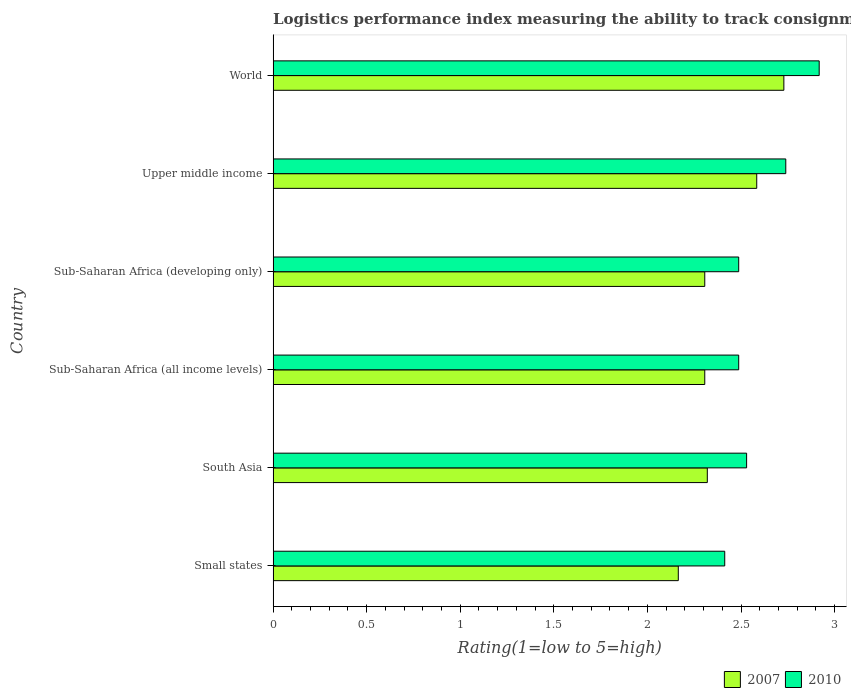How many different coloured bars are there?
Provide a succinct answer. 2. How many groups of bars are there?
Offer a very short reply. 6. Are the number of bars per tick equal to the number of legend labels?
Your answer should be very brief. Yes. Are the number of bars on each tick of the Y-axis equal?
Keep it short and to the point. Yes. How many bars are there on the 5th tick from the top?
Provide a succinct answer. 2. How many bars are there on the 2nd tick from the bottom?
Your response must be concise. 2. In how many cases, is the number of bars for a given country not equal to the number of legend labels?
Your response must be concise. 0. What is the Logistic performance index in 2010 in Upper middle income?
Keep it short and to the point. 2.74. Across all countries, what is the maximum Logistic performance index in 2010?
Give a very brief answer. 2.92. Across all countries, what is the minimum Logistic performance index in 2010?
Provide a short and direct response. 2.41. In which country was the Logistic performance index in 2010 minimum?
Provide a short and direct response. Small states. What is the total Logistic performance index in 2007 in the graph?
Your answer should be very brief. 14.41. What is the difference between the Logistic performance index in 2007 in South Asia and that in Upper middle income?
Provide a succinct answer. -0.26. What is the difference between the Logistic performance index in 2007 in South Asia and the Logistic performance index in 2010 in Upper middle income?
Provide a short and direct response. -0.42. What is the average Logistic performance index in 2010 per country?
Offer a very short reply. 2.6. What is the difference between the Logistic performance index in 2007 and Logistic performance index in 2010 in South Asia?
Your answer should be compact. -0.21. What is the ratio of the Logistic performance index in 2007 in Sub-Saharan Africa (developing only) to that in World?
Give a very brief answer. 0.85. Is the Logistic performance index in 2007 in Small states less than that in South Asia?
Your answer should be compact. Yes. What is the difference between the highest and the second highest Logistic performance index in 2010?
Your answer should be compact. 0.18. What is the difference between the highest and the lowest Logistic performance index in 2007?
Provide a succinct answer. 0.56. Is the sum of the Logistic performance index in 2007 in Sub-Saharan Africa (all income levels) and World greater than the maximum Logistic performance index in 2010 across all countries?
Ensure brevity in your answer.  Yes. What does the 1st bar from the top in World represents?
Give a very brief answer. 2010. How many countries are there in the graph?
Keep it short and to the point. 6. What is the difference between two consecutive major ticks on the X-axis?
Provide a succinct answer. 0.5. Does the graph contain any zero values?
Your answer should be very brief. No. Does the graph contain grids?
Offer a very short reply. No. What is the title of the graph?
Give a very brief answer. Logistics performance index measuring the ability to track consignments when shipping to a market. What is the label or title of the X-axis?
Offer a very short reply. Rating(1=low to 5=high). What is the label or title of the Y-axis?
Give a very brief answer. Country. What is the Rating(1=low to 5=high) of 2007 in Small states?
Provide a succinct answer. 2.17. What is the Rating(1=low to 5=high) of 2010 in Small states?
Your answer should be very brief. 2.41. What is the Rating(1=low to 5=high) in 2007 in South Asia?
Your answer should be compact. 2.32. What is the Rating(1=low to 5=high) of 2010 in South Asia?
Your answer should be compact. 2.53. What is the Rating(1=low to 5=high) of 2007 in Sub-Saharan Africa (all income levels)?
Your answer should be compact. 2.31. What is the Rating(1=low to 5=high) of 2010 in Sub-Saharan Africa (all income levels)?
Make the answer very short. 2.49. What is the Rating(1=low to 5=high) in 2007 in Sub-Saharan Africa (developing only)?
Your answer should be very brief. 2.31. What is the Rating(1=low to 5=high) of 2010 in Sub-Saharan Africa (developing only)?
Your answer should be compact. 2.49. What is the Rating(1=low to 5=high) of 2007 in Upper middle income?
Offer a terse response. 2.58. What is the Rating(1=low to 5=high) in 2010 in Upper middle income?
Provide a short and direct response. 2.74. What is the Rating(1=low to 5=high) in 2007 in World?
Offer a very short reply. 2.73. What is the Rating(1=low to 5=high) of 2010 in World?
Your answer should be compact. 2.92. Across all countries, what is the maximum Rating(1=low to 5=high) of 2007?
Your response must be concise. 2.73. Across all countries, what is the maximum Rating(1=low to 5=high) in 2010?
Your answer should be very brief. 2.92. Across all countries, what is the minimum Rating(1=low to 5=high) in 2007?
Your answer should be compact. 2.17. Across all countries, what is the minimum Rating(1=low to 5=high) in 2010?
Give a very brief answer. 2.41. What is the total Rating(1=low to 5=high) in 2007 in the graph?
Offer a terse response. 14.41. What is the total Rating(1=low to 5=high) of 2010 in the graph?
Your answer should be very brief. 15.58. What is the difference between the Rating(1=low to 5=high) in 2007 in Small states and that in South Asia?
Give a very brief answer. -0.15. What is the difference between the Rating(1=low to 5=high) of 2010 in Small states and that in South Asia?
Offer a very short reply. -0.12. What is the difference between the Rating(1=low to 5=high) in 2007 in Small states and that in Sub-Saharan Africa (all income levels)?
Ensure brevity in your answer.  -0.14. What is the difference between the Rating(1=low to 5=high) of 2010 in Small states and that in Sub-Saharan Africa (all income levels)?
Ensure brevity in your answer.  -0.07. What is the difference between the Rating(1=low to 5=high) in 2007 in Small states and that in Sub-Saharan Africa (developing only)?
Make the answer very short. -0.14. What is the difference between the Rating(1=low to 5=high) of 2010 in Small states and that in Sub-Saharan Africa (developing only)?
Ensure brevity in your answer.  -0.07. What is the difference between the Rating(1=low to 5=high) in 2007 in Small states and that in Upper middle income?
Give a very brief answer. -0.42. What is the difference between the Rating(1=low to 5=high) of 2010 in Small states and that in Upper middle income?
Make the answer very short. -0.33. What is the difference between the Rating(1=low to 5=high) in 2007 in Small states and that in World?
Provide a short and direct response. -0.56. What is the difference between the Rating(1=low to 5=high) in 2010 in Small states and that in World?
Keep it short and to the point. -0.5. What is the difference between the Rating(1=low to 5=high) in 2007 in South Asia and that in Sub-Saharan Africa (all income levels)?
Your answer should be very brief. 0.01. What is the difference between the Rating(1=low to 5=high) in 2010 in South Asia and that in Sub-Saharan Africa (all income levels)?
Your response must be concise. 0.04. What is the difference between the Rating(1=low to 5=high) of 2007 in South Asia and that in Sub-Saharan Africa (developing only)?
Keep it short and to the point. 0.01. What is the difference between the Rating(1=low to 5=high) of 2010 in South Asia and that in Sub-Saharan Africa (developing only)?
Your answer should be very brief. 0.04. What is the difference between the Rating(1=low to 5=high) in 2007 in South Asia and that in Upper middle income?
Provide a short and direct response. -0.26. What is the difference between the Rating(1=low to 5=high) of 2010 in South Asia and that in Upper middle income?
Your answer should be compact. -0.21. What is the difference between the Rating(1=low to 5=high) in 2007 in South Asia and that in World?
Offer a very short reply. -0.41. What is the difference between the Rating(1=low to 5=high) in 2010 in South Asia and that in World?
Offer a very short reply. -0.39. What is the difference between the Rating(1=low to 5=high) of 2010 in Sub-Saharan Africa (all income levels) and that in Sub-Saharan Africa (developing only)?
Your answer should be very brief. 0. What is the difference between the Rating(1=low to 5=high) of 2007 in Sub-Saharan Africa (all income levels) and that in Upper middle income?
Provide a short and direct response. -0.28. What is the difference between the Rating(1=low to 5=high) of 2010 in Sub-Saharan Africa (all income levels) and that in Upper middle income?
Provide a succinct answer. -0.25. What is the difference between the Rating(1=low to 5=high) of 2007 in Sub-Saharan Africa (all income levels) and that in World?
Keep it short and to the point. -0.42. What is the difference between the Rating(1=low to 5=high) of 2010 in Sub-Saharan Africa (all income levels) and that in World?
Your answer should be compact. -0.43. What is the difference between the Rating(1=low to 5=high) of 2007 in Sub-Saharan Africa (developing only) and that in Upper middle income?
Give a very brief answer. -0.28. What is the difference between the Rating(1=low to 5=high) in 2010 in Sub-Saharan Africa (developing only) and that in Upper middle income?
Make the answer very short. -0.25. What is the difference between the Rating(1=low to 5=high) in 2007 in Sub-Saharan Africa (developing only) and that in World?
Offer a terse response. -0.42. What is the difference between the Rating(1=low to 5=high) in 2010 in Sub-Saharan Africa (developing only) and that in World?
Provide a succinct answer. -0.43. What is the difference between the Rating(1=low to 5=high) in 2007 in Upper middle income and that in World?
Provide a short and direct response. -0.14. What is the difference between the Rating(1=low to 5=high) of 2010 in Upper middle income and that in World?
Keep it short and to the point. -0.18. What is the difference between the Rating(1=low to 5=high) of 2007 in Small states and the Rating(1=low to 5=high) of 2010 in South Asia?
Ensure brevity in your answer.  -0.36. What is the difference between the Rating(1=low to 5=high) in 2007 in Small states and the Rating(1=low to 5=high) in 2010 in Sub-Saharan Africa (all income levels)?
Offer a terse response. -0.32. What is the difference between the Rating(1=low to 5=high) in 2007 in Small states and the Rating(1=low to 5=high) in 2010 in Sub-Saharan Africa (developing only)?
Your answer should be very brief. -0.32. What is the difference between the Rating(1=low to 5=high) in 2007 in Small states and the Rating(1=low to 5=high) in 2010 in Upper middle income?
Keep it short and to the point. -0.57. What is the difference between the Rating(1=low to 5=high) in 2007 in Small states and the Rating(1=low to 5=high) in 2010 in World?
Your response must be concise. -0.75. What is the difference between the Rating(1=low to 5=high) in 2007 in South Asia and the Rating(1=low to 5=high) in 2010 in Sub-Saharan Africa (all income levels)?
Give a very brief answer. -0.17. What is the difference between the Rating(1=low to 5=high) of 2007 in South Asia and the Rating(1=low to 5=high) of 2010 in Sub-Saharan Africa (developing only)?
Your answer should be very brief. -0.17. What is the difference between the Rating(1=low to 5=high) in 2007 in South Asia and the Rating(1=low to 5=high) in 2010 in Upper middle income?
Make the answer very short. -0.42. What is the difference between the Rating(1=low to 5=high) of 2007 in South Asia and the Rating(1=low to 5=high) of 2010 in World?
Your response must be concise. -0.6. What is the difference between the Rating(1=low to 5=high) in 2007 in Sub-Saharan Africa (all income levels) and the Rating(1=low to 5=high) in 2010 in Sub-Saharan Africa (developing only)?
Your answer should be compact. -0.18. What is the difference between the Rating(1=low to 5=high) in 2007 in Sub-Saharan Africa (all income levels) and the Rating(1=low to 5=high) in 2010 in Upper middle income?
Offer a terse response. -0.43. What is the difference between the Rating(1=low to 5=high) in 2007 in Sub-Saharan Africa (all income levels) and the Rating(1=low to 5=high) in 2010 in World?
Offer a terse response. -0.61. What is the difference between the Rating(1=low to 5=high) of 2007 in Sub-Saharan Africa (developing only) and the Rating(1=low to 5=high) of 2010 in Upper middle income?
Your answer should be compact. -0.43. What is the difference between the Rating(1=low to 5=high) in 2007 in Sub-Saharan Africa (developing only) and the Rating(1=low to 5=high) in 2010 in World?
Give a very brief answer. -0.61. What is the difference between the Rating(1=low to 5=high) of 2007 in Upper middle income and the Rating(1=low to 5=high) of 2010 in World?
Offer a terse response. -0.33. What is the average Rating(1=low to 5=high) of 2007 per country?
Ensure brevity in your answer.  2.4. What is the average Rating(1=low to 5=high) of 2010 per country?
Keep it short and to the point. 2.6. What is the difference between the Rating(1=low to 5=high) of 2007 and Rating(1=low to 5=high) of 2010 in Small states?
Your answer should be compact. -0.25. What is the difference between the Rating(1=low to 5=high) in 2007 and Rating(1=low to 5=high) in 2010 in South Asia?
Ensure brevity in your answer.  -0.21. What is the difference between the Rating(1=low to 5=high) in 2007 and Rating(1=low to 5=high) in 2010 in Sub-Saharan Africa (all income levels)?
Your answer should be very brief. -0.18. What is the difference between the Rating(1=low to 5=high) of 2007 and Rating(1=low to 5=high) of 2010 in Sub-Saharan Africa (developing only)?
Your answer should be compact. -0.18. What is the difference between the Rating(1=low to 5=high) in 2007 and Rating(1=low to 5=high) in 2010 in Upper middle income?
Offer a terse response. -0.16. What is the difference between the Rating(1=low to 5=high) in 2007 and Rating(1=low to 5=high) in 2010 in World?
Offer a terse response. -0.19. What is the ratio of the Rating(1=low to 5=high) in 2007 in Small states to that in South Asia?
Offer a terse response. 0.93. What is the ratio of the Rating(1=low to 5=high) in 2010 in Small states to that in South Asia?
Ensure brevity in your answer.  0.95. What is the ratio of the Rating(1=low to 5=high) of 2007 in Small states to that in Sub-Saharan Africa (all income levels)?
Offer a terse response. 0.94. What is the ratio of the Rating(1=low to 5=high) of 2010 in Small states to that in Sub-Saharan Africa (all income levels)?
Provide a short and direct response. 0.97. What is the ratio of the Rating(1=low to 5=high) of 2007 in Small states to that in Sub-Saharan Africa (developing only)?
Your answer should be compact. 0.94. What is the ratio of the Rating(1=low to 5=high) in 2010 in Small states to that in Sub-Saharan Africa (developing only)?
Offer a very short reply. 0.97. What is the ratio of the Rating(1=low to 5=high) in 2007 in Small states to that in Upper middle income?
Your response must be concise. 0.84. What is the ratio of the Rating(1=low to 5=high) of 2010 in Small states to that in Upper middle income?
Make the answer very short. 0.88. What is the ratio of the Rating(1=low to 5=high) of 2007 in Small states to that in World?
Keep it short and to the point. 0.79. What is the ratio of the Rating(1=low to 5=high) of 2010 in Small states to that in World?
Your answer should be compact. 0.83. What is the ratio of the Rating(1=low to 5=high) of 2007 in South Asia to that in Sub-Saharan Africa (all income levels)?
Your answer should be very brief. 1.01. What is the ratio of the Rating(1=low to 5=high) in 2007 in South Asia to that in Sub-Saharan Africa (developing only)?
Ensure brevity in your answer.  1.01. What is the ratio of the Rating(1=low to 5=high) in 2010 in South Asia to that in Sub-Saharan Africa (developing only)?
Offer a terse response. 1.02. What is the ratio of the Rating(1=low to 5=high) in 2007 in South Asia to that in Upper middle income?
Offer a very short reply. 0.9. What is the ratio of the Rating(1=low to 5=high) in 2010 in South Asia to that in Upper middle income?
Keep it short and to the point. 0.92. What is the ratio of the Rating(1=low to 5=high) in 2007 in South Asia to that in World?
Ensure brevity in your answer.  0.85. What is the ratio of the Rating(1=low to 5=high) in 2010 in South Asia to that in World?
Your answer should be very brief. 0.87. What is the ratio of the Rating(1=low to 5=high) of 2010 in Sub-Saharan Africa (all income levels) to that in Sub-Saharan Africa (developing only)?
Give a very brief answer. 1. What is the ratio of the Rating(1=low to 5=high) of 2007 in Sub-Saharan Africa (all income levels) to that in Upper middle income?
Your answer should be compact. 0.89. What is the ratio of the Rating(1=low to 5=high) of 2010 in Sub-Saharan Africa (all income levels) to that in Upper middle income?
Make the answer very short. 0.91. What is the ratio of the Rating(1=low to 5=high) in 2007 in Sub-Saharan Africa (all income levels) to that in World?
Provide a short and direct response. 0.85. What is the ratio of the Rating(1=low to 5=high) in 2010 in Sub-Saharan Africa (all income levels) to that in World?
Give a very brief answer. 0.85. What is the ratio of the Rating(1=low to 5=high) of 2007 in Sub-Saharan Africa (developing only) to that in Upper middle income?
Provide a short and direct response. 0.89. What is the ratio of the Rating(1=low to 5=high) of 2010 in Sub-Saharan Africa (developing only) to that in Upper middle income?
Provide a short and direct response. 0.91. What is the ratio of the Rating(1=low to 5=high) of 2007 in Sub-Saharan Africa (developing only) to that in World?
Provide a short and direct response. 0.85. What is the ratio of the Rating(1=low to 5=high) in 2010 in Sub-Saharan Africa (developing only) to that in World?
Your response must be concise. 0.85. What is the ratio of the Rating(1=low to 5=high) in 2007 in Upper middle income to that in World?
Keep it short and to the point. 0.95. What is the ratio of the Rating(1=low to 5=high) of 2010 in Upper middle income to that in World?
Provide a short and direct response. 0.94. What is the difference between the highest and the second highest Rating(1=low to 5=high) in 2007?
Offer a terse response. 0.14. What is the difference between the highest and the second highest Rating(1=low to 5=high) in 2010?
Keep it short and to the point. 0.18. What is the difference between the highest and the lowest Rating(1=low to 5=high) of 2007?
Provide a short and direct response. 0.56. What is the difference between the highest and the lowest Rating(1=low to 5=high) of 2010?
Offer a very short reply. 0.5. 